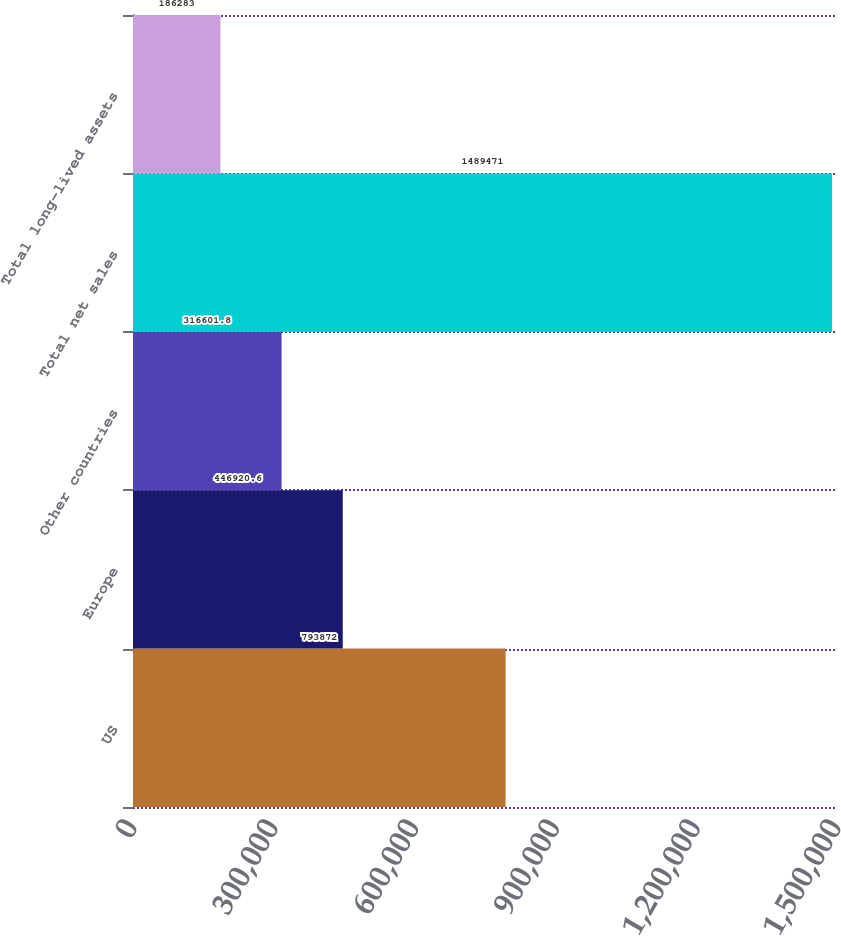<chart> <loc_0><loc_0><loc_500><loc_500><bar_chart><fcel>US<fcel>Europe<fcel>Other countries<fcel>Total net sales<fcel>Total long-lived assets<nl><fcel>793872<fcel>446921<fcel>316602<fcel>1.48947e+06<fcel>186283<nl></chart> 